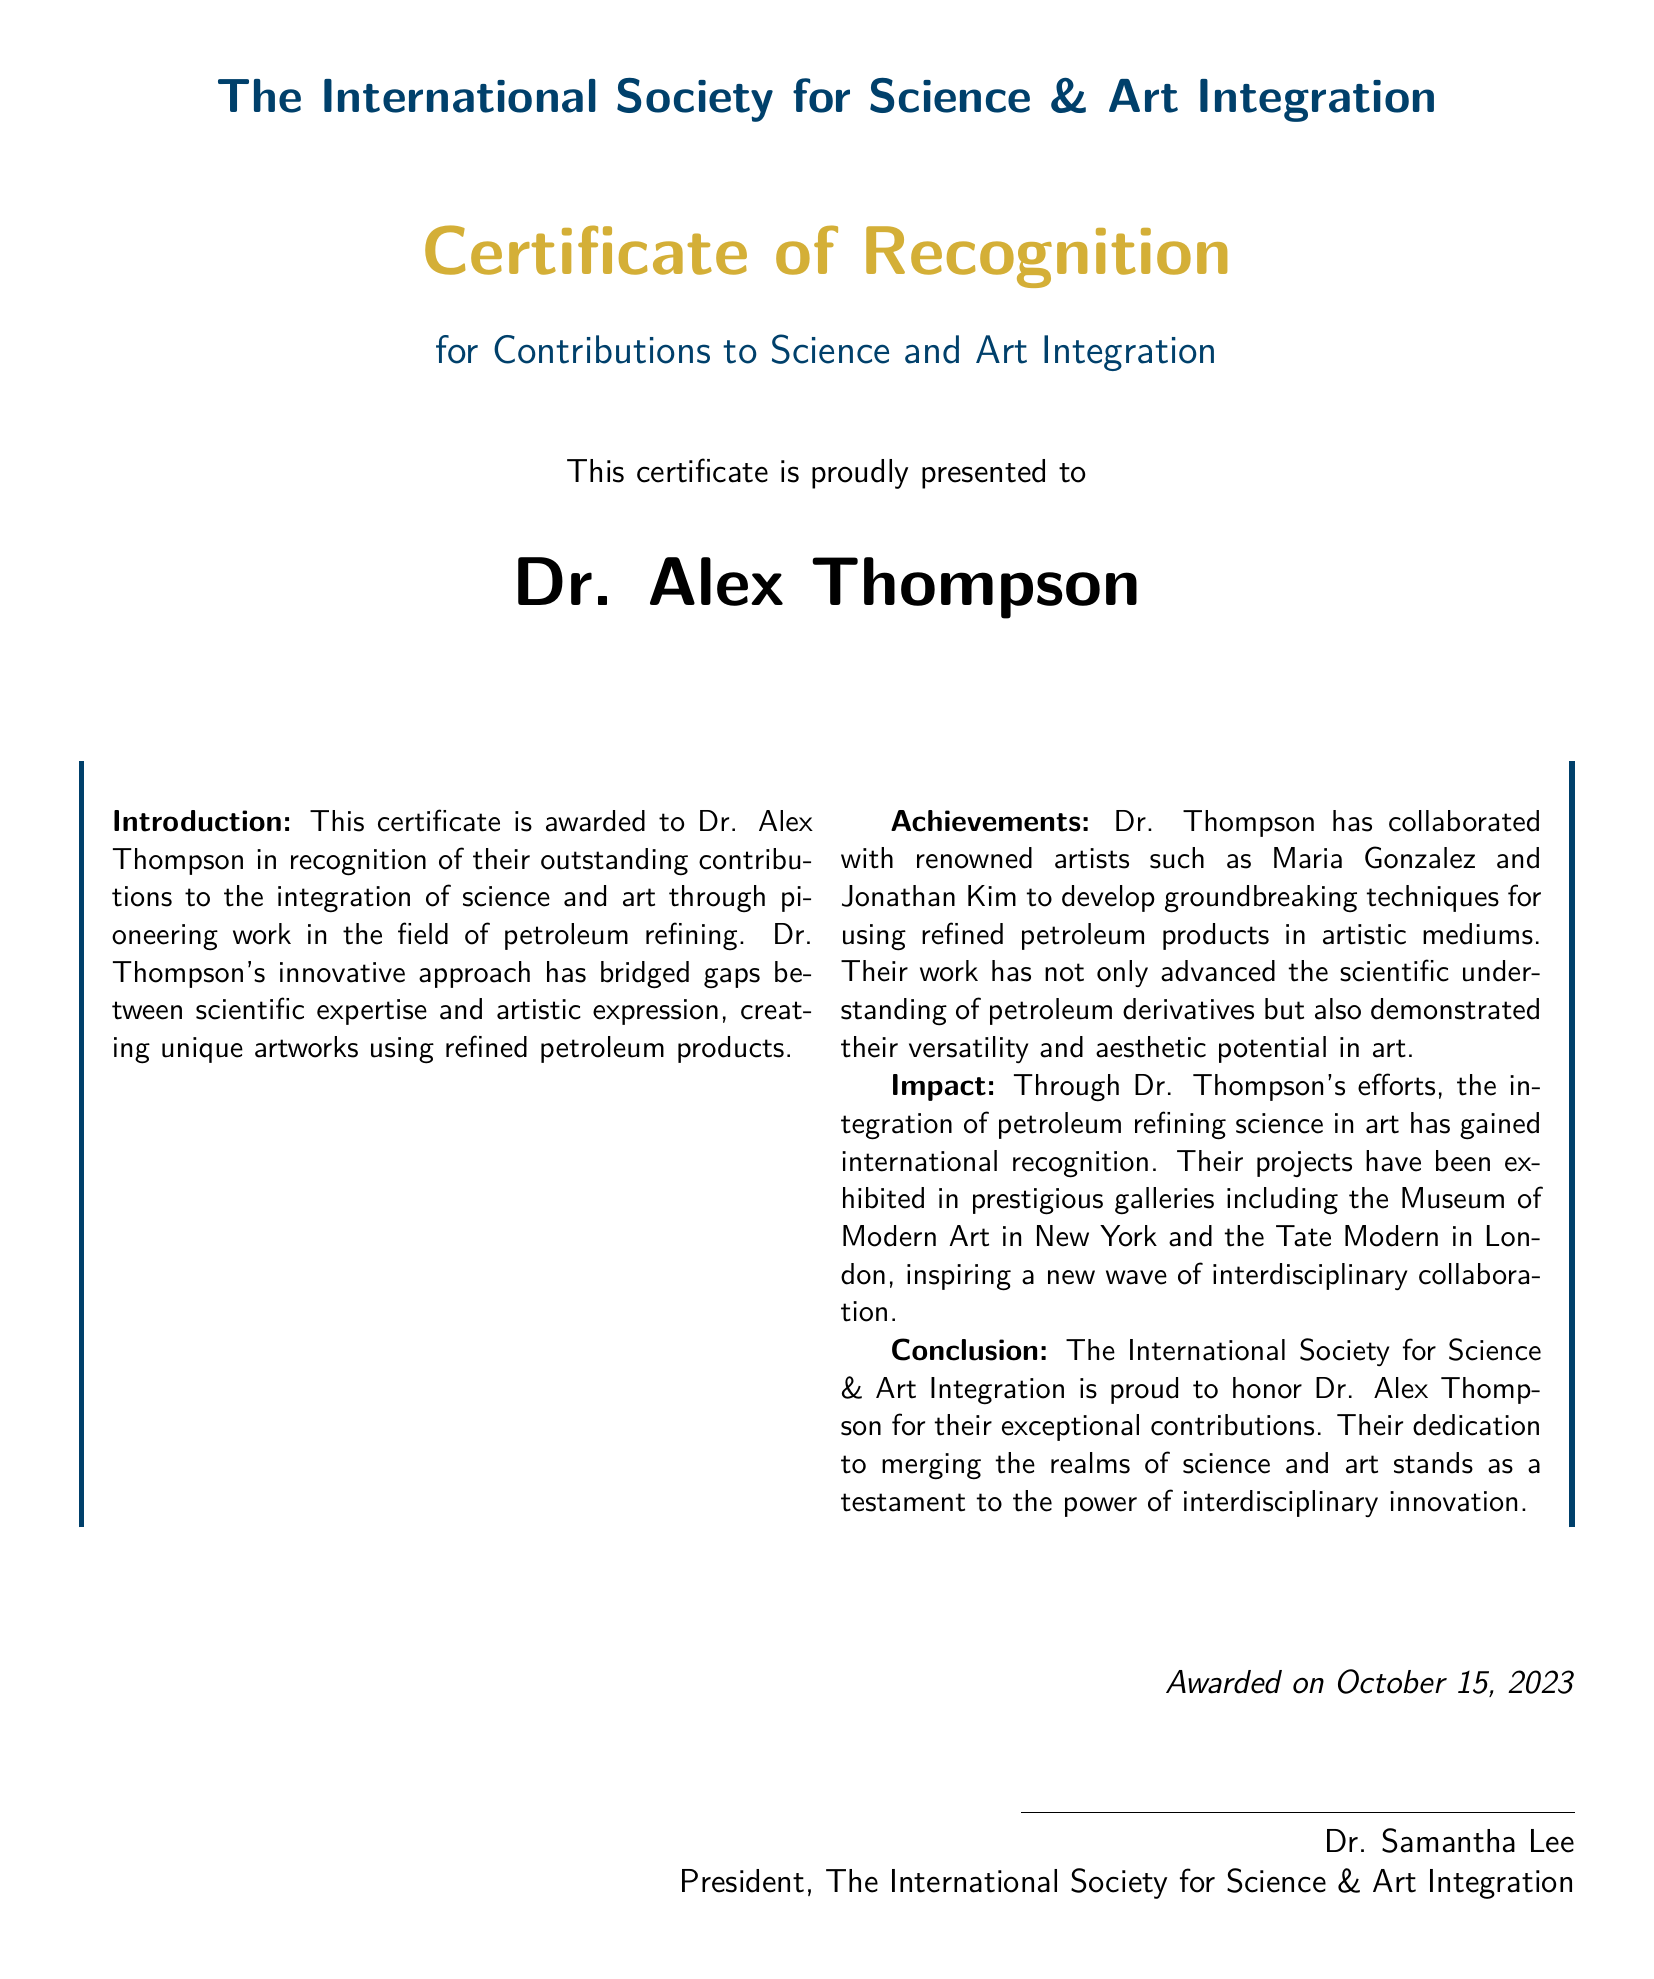What is the name of the recipient? The document displays the name of the recipient prominently, which is Dr. Alex Thompson.
Answer: Dr. Alex Thompson Who presented the certificate? The certificate includes the name and title of the presenter, which is Dr. Samantha Lee, President of the Society.
Answer: Dr. Samantha Lee On what date was the certificate awarded? The document states the award date as October 15, 2023.
Answer: October 15, 2023 What is the main purpose of the certificate? The purpose stated in the certificate is to recognize contributions to the integration of science and art.
Answer: Contributions to Science and Art Integration Which two artists are mentioned in the context of Dr. Thompson’s collaborations? The document includes the names of the renowned artists Dr. Thompson collaborated with: Maria Gonzalez and Jonathan Kim.
Answer: Maria Gonzalez and Jonathan Kim What artistic medium does Dr. Thompson work with? The certificate mentions that Dr. Thompson uses refined petroleum products in artistic mediums.
Answer: Refined petroleum products What prestigious galleries exhibited Dr. Thompson's projects? The document identifies the Museum of Modern Art in New York and the Tate Modern in London as venues for Dr. Thompson's projects.
Answer: Museum of Modern Art in New York and Tate Modern in London What color is primarily used for the title "Certificate of Recognition"? The title "Certificate of Recognition" is highlighted in the color art gold.
Answer: Art gold What society awarded this certificate? The name of the society that awarded the certificate is The International Society for Science & Art Integration.
Answer: The International Society for Science & Art Integration 